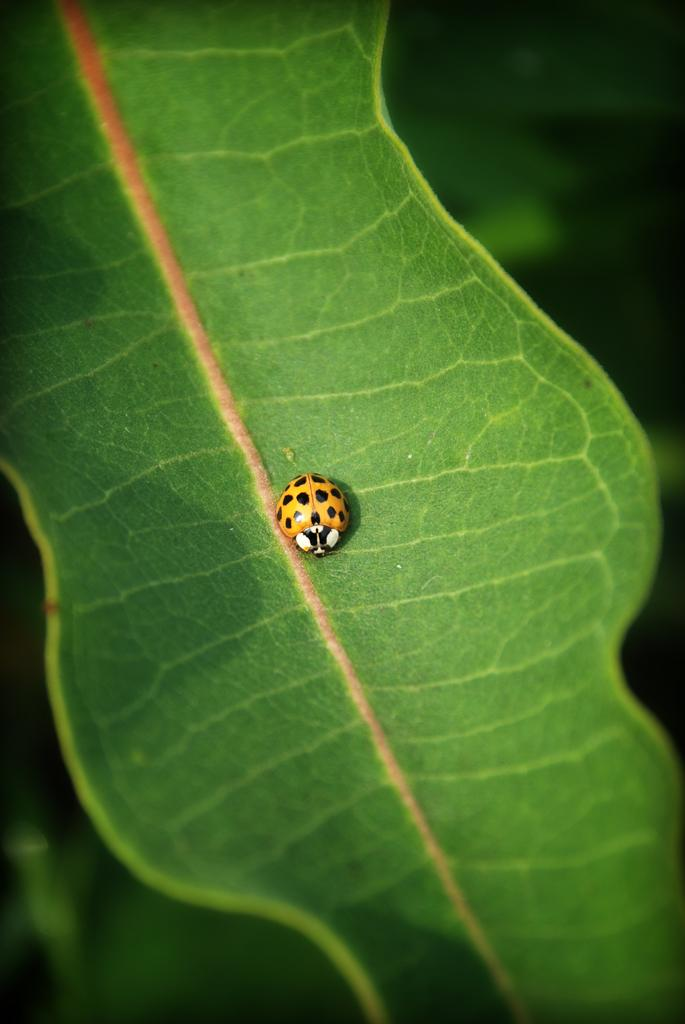What type of insect is in the image? There is a yellow insect in the image. Where is the insect located? The insect is sitting on a green leaf. Can you describe the background of the image? The background of the image is blurred. What is the name of the patch on the insect's back in the image? There is no patch on the insect's back in the image, and the insect's name is not mentioned in the image. 